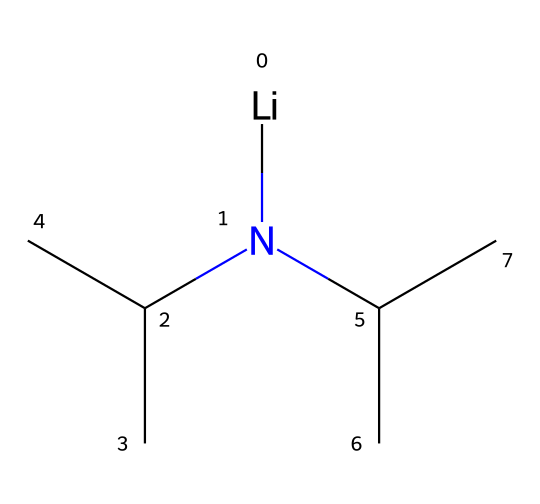What is the chemical name of this compound? The SMILES representation provided corresponds to lithium diisopropylamide, which is verified by identifying the lithium (Li) and the amide group (N bonded to isopropyl carbon groups).
Answer: lithium diisopropylamide How many carbon atoms are in this molecule? The structure has six carbon atoms in total, counted from the two isopropyl groups attached to the nitrogen atom, and one carbon linked to the lithium.
Answer: six What is the functional group present in this compound? The presence of the nitrogen atom (N) bonded to carbon indicates that this compound has an amide functional group characteristic of superbases like LDA.
Answer: amide How many branches (alkyl groups) are present in the structure? There are two isopropyl groups branching off the nitrogen, which constitutes two branches in the chemical structure overall.
Answer: two Why is lithium diisopropylamide considered a superbase? This compound is classified as a superbase due to its ability to deprotonate relatively weak acids effectively. In this particular structure, the nitrogen's lone pair can easily abstract protons from nearby acids.
Answer: deprotonation ability What is the oxidation state of lithium in this compound? The lithium atom (Li) in this compound is in the +1 oxidation state, which is typical for alkali metals that usually lose one electron to form cations.
Answer: +1 